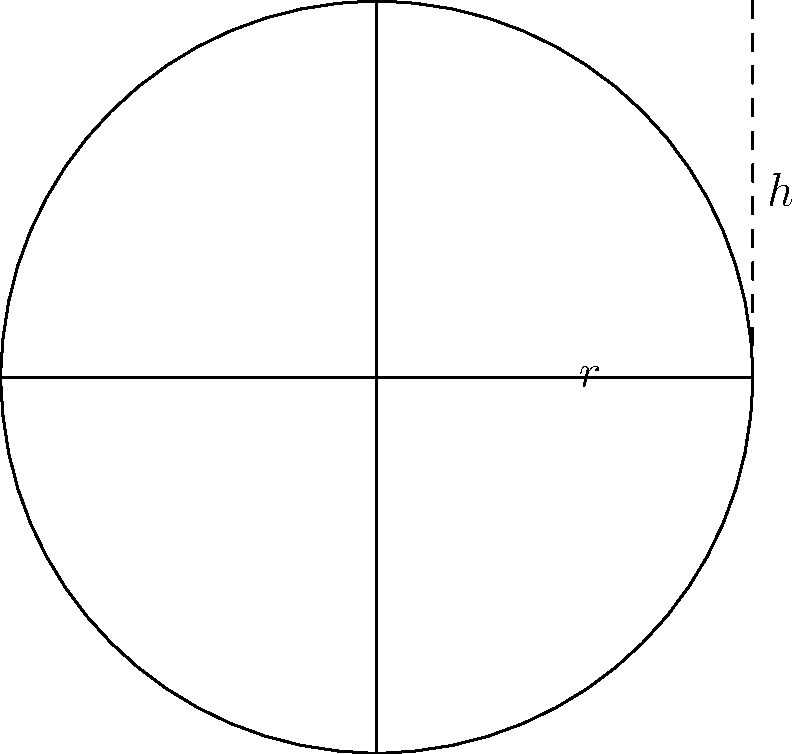Your cousin Otis Yelton is working on a farm project and needs to estimate the volume of a cylindrical water tank. He provides you with a simple sketch showing the tank's dimensions. If the radius ($r$) is 3 feet and the height ($h$) is 8 feet, what is the approximate volume of the tank in cubic feet? Round your answer to the nearest whole number. To find the volume of a cylindrical tank, we use the formula:

$$V = \pi r^2 h$$

Where:
$V$ = volume
$r$ = radius
$h$ = height

Let's plug in the values:

$r = 3$ feet
$h = 8$ feet

$$V = \pi (3\text{ ft})^2 (8\text{ ft})$$

$$V = \pi (9\text{ ft}^2) (8\text{ ft})$$

$$V = 72\pi\text{ ft}^3$$

Using $\pi \approx 3.14159$:

$$V \approx 72 \times 3.14159\text{ ft}^3$$

$$V \approx 226.19\text{ ft}^3$$

Rounding to the nearest whole number:

$$V \approx 226\text{ ft}^3$$
Answer: 226 cubic feet 